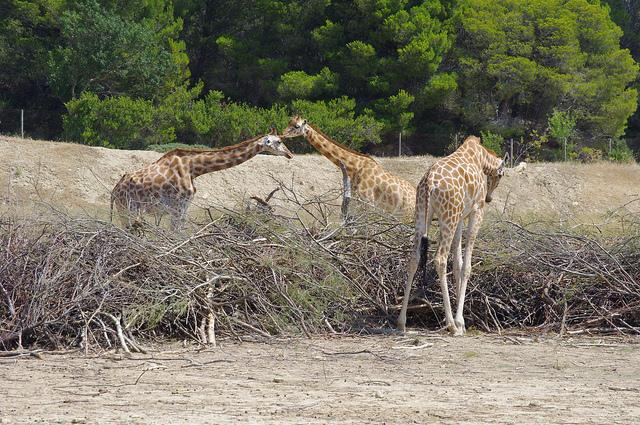Are the animals the same species?
Quick response, please. Yes. Are the giraffes the same size?
Concise answer only. Yes. How many animals?
Quick response, please. 3. How many giraffes are there?
Short answer required. 3. What color are the trees in the background?
Be succinct. Green. What color is the small animal?
Concise answer only. Brown. Where is the giraffe?
Quick response, please. Wild. Is this a wild horse?
Short answer required. No. Is there a bird on the ground?
Concise answer only. No. Is the grass green?
Give a very brief answer. No. What animal is shown?
Answer briefly. Giraffe. 